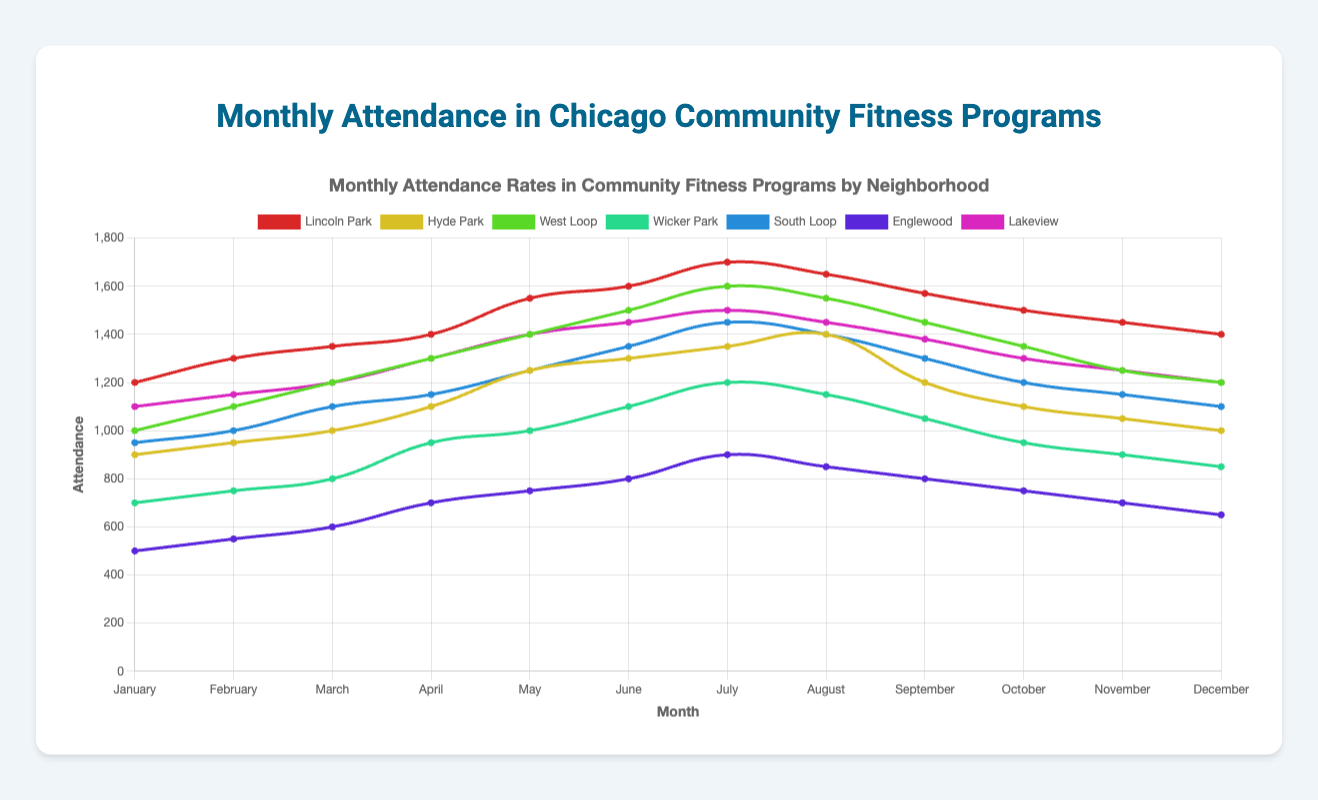Which neighborhood has the highest attendance in June? The June attendance for each neighborhood is: Lincoln Park (1600), Hyde Park (1300), West Loop (1500), Wicker Park (1100), South Loop (1350), Englewood (800), Lakeview (1450). Among these, Lincoln Park has the highest attendance.
Answer: Lincoln Park Which neighborhoods have decreasing attendance rates from July to December? Check the attendance rates from July to December for each neighborhood: Lincoln Park (1700 to 1400), Hyde Park (1350 to 1000), West Loop (1600 to 1200), Wicker Park (1200 to 850), South Loop (1450 to 1100), Englewood (900 to 650), Lakeview (1500 to 1200). All the neighborhoods mentioned have decreasing attendance rates from July to December.
Answer: All neighborhoods What is the average monthly attendance for Lakeview from January to June? The attendance for Lakeview from January to June is: 1100, 1150, 1200, 1300, 1400, 1450. The sum is 7600. The average is 7600 / 6 = 1266.67.
Answer: 1266.67 How does the attendance in Lincoln Park compare between January and August? The attendance in Lincoln Park in January is 1200 and in August is 1650. Comparing the two, August's attendance is higher than January's.
Answer: August is higher Which neighborhood has the lowest attendance in January? The attendance in January for each neighborhood is: Lincoln Park (1200), Hyde Park (900), West Loop (1000), Wicker Park (700), South Loop (950), Englewood (500), Lakeview (1100). Englewood has the lowest attendance.
Answer: Englewood What is the total attendance for Hyde Park over the year? Sum the monthly attendance for Hyde Park: 900 + 950 + 1000 + 1100 + 1250 + 1300 + 1350 + 1400 + 1200 + 1100 + 1050 + 1000 = 13600.
Answer: 13600 Between which two consecutive months did West Loop experience the greatest drop in attendance? Check the differences between consecutive months for West Loop:
- February - January = 100 (1100 - 1000)
- March - February = 100 (1200 - 1100)
- April - March = 100 (1300 - 1200)
- May - April = 100 (1400 - 1300)
- June - May = 100 (1500 - 1400)
- July - June = 100 (1600 - 1500)
- August - July = -50 (1550 - 1600)
- September - August = -100 (1450 - 1550)
- October - September = -100 (1350 - 1450)
- November - October = -100 (1250 - 1350)
- December - November = -50 (1200 - 1250)
The greatest drop is between August and September with a drop of 100.
Answer: August and September What is the median attendance in December across all neighborhoods? List the December attendances: 1400, 1000, 1200, 850, 1100, 650, 1200. Arrange them in order: 650, 850, 1000, 1100, 1200, 1200, 1400. The median (middle value) is 1100.
Answer: 1100 Which neighborhood has a higher attendance rate in May, Hyde Park or South Loop? The attendance in May for Hyde Park is 1250, and for South Loop, it is also 1250. Both neighborhoods have equal attendance rates in May.
Answer: Equal Which month shows a peak in attendance for Englewood? For Englewood, the attendance each month is: January (500), February (550), March (600), April (700), May (750), June (800), July (900), August (850), September (800), October (750), November (700), December (650). The peak attendance is in July with 900 attendees.
Answer: July 